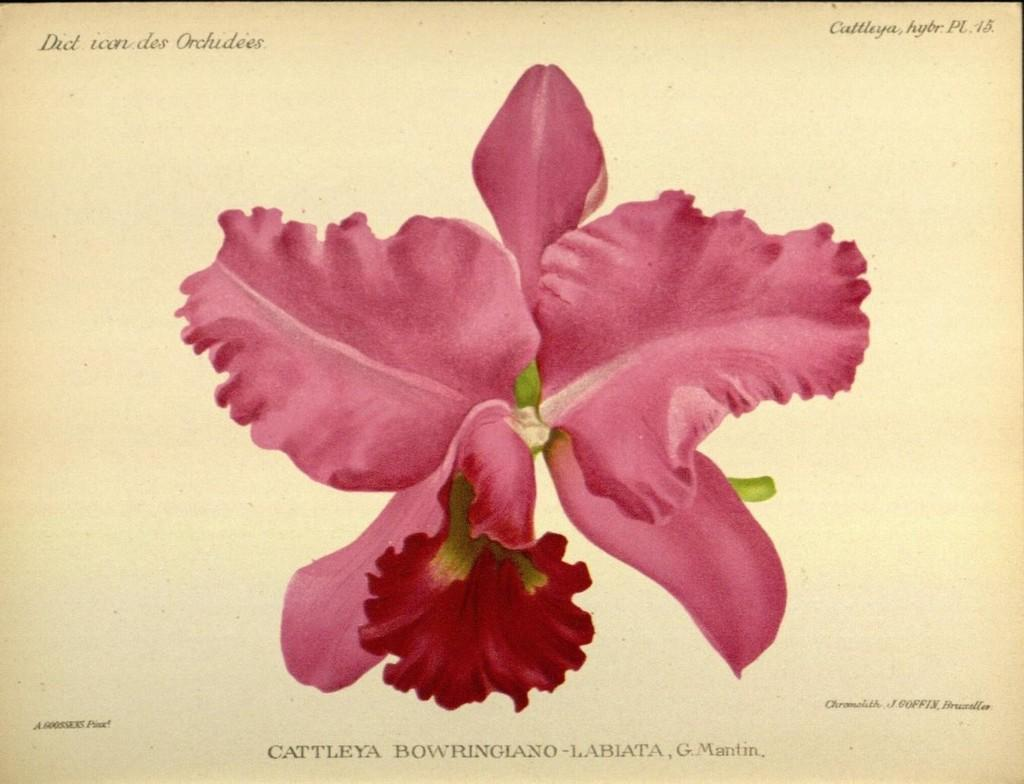What type of flower is present in the image? There is a pink flower in the image. What can be seen at the top of the image? There is text at the top of the image. What can be seen at the bottom of the image? There is text at the bottom of the image. How is the image presented? The image appears to be printed on paper. What type of sail can be seen in the image? There is no sail present in the image. What arithmetic problem is being solved in the image? There is no arithmetic problem present in the image. 